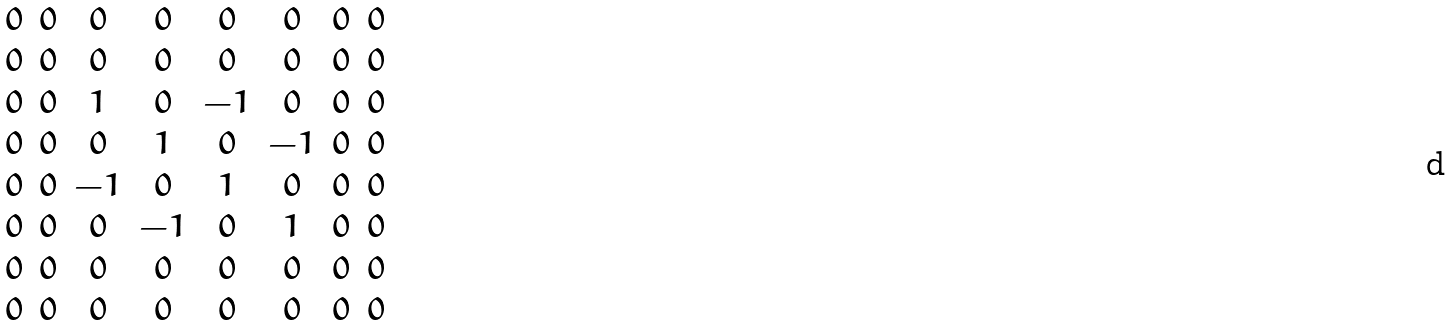Convert formula to latex. <formula><loc_0><loc_0><loc_500><loc_500>\begin{matrix} 0 & 0 & 0 & 0 & 0 & 0 & 0 & 0 \\ 0 & 0 & 0 & 0 & 0 & 0 & 0 & 0 \\ 0 & 0 & 1 & 0 & - 1 & 0 & 0 & 0 \\ 0 & 0 & 0 & 1 & 0 & - 1 & 0 & 0 \\ 0 & 0 & - 1 & 0 & 1 & 0 & 0 & 0 \\ 0 & 0 & 0 & - 1 & 0 & 1 & 0 & 0 \\ 0 & 0 & 0 & 0 & 0 & 0 & 0 & 0 \\ 0 & 0 & 0 & 0 & 0 & 0 & 0 & 0 \end{matrix}</formula> 